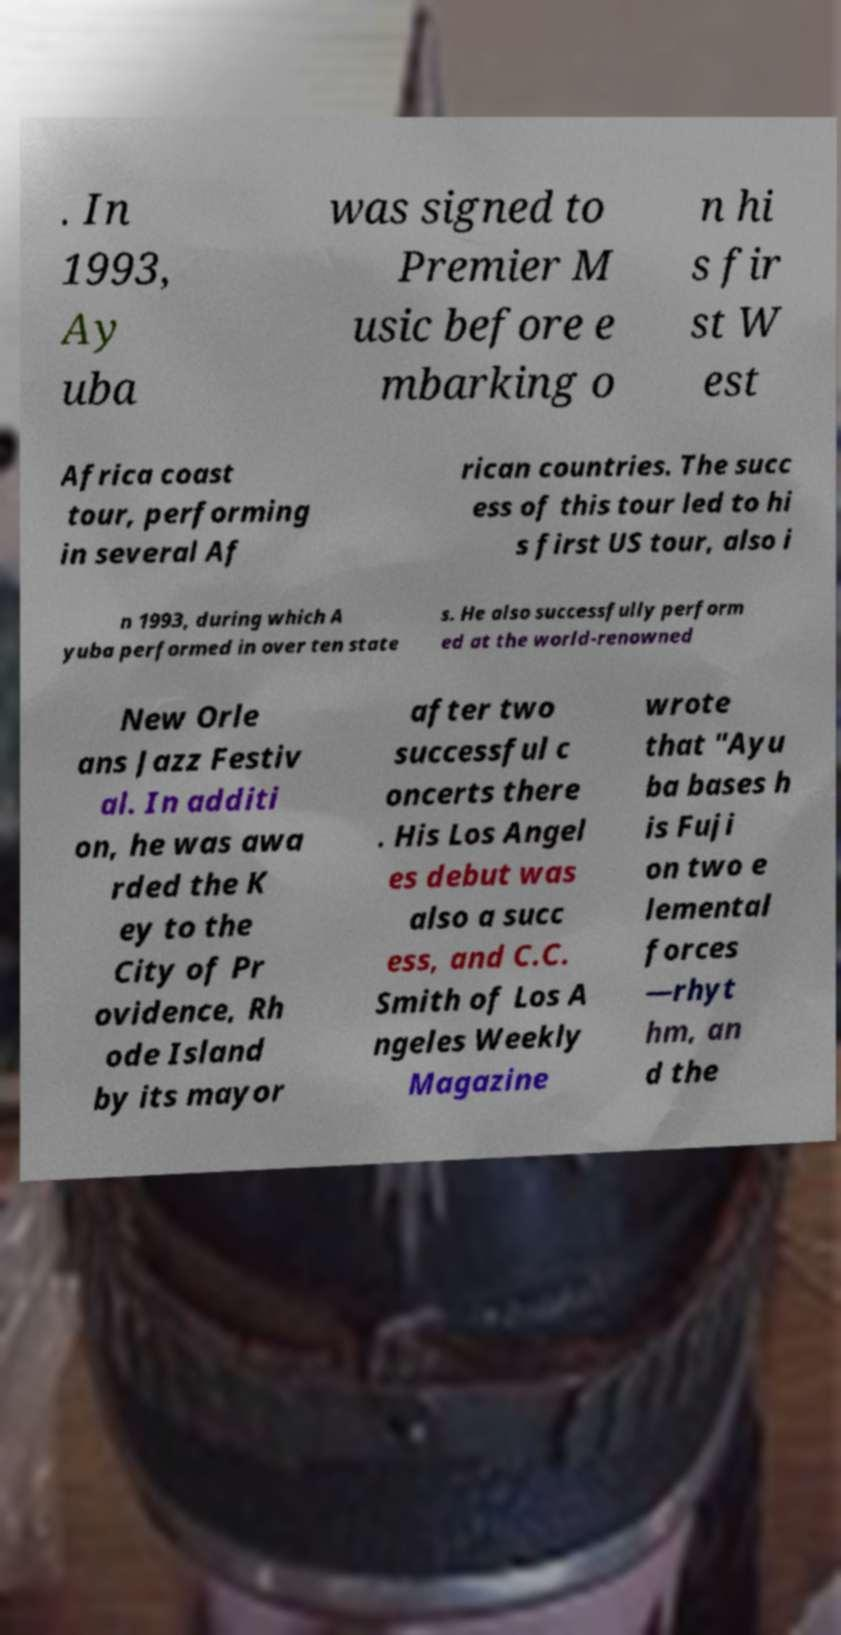Could you assist in decoding the text presented in this image and type it out clearly? . In 1993, Ay uba was signed to Premier M usic before e mbarking o n hi s fir st W est Africa coast tour, performing in several Af rican countries. The succ ess of this tour led to hi s first US tour, also i n 1993, during which A yuba performed in over ten state s. He also successfully perform ed at the world-renowned New Orle ans Jazz Festiv al. In additi on, he was awa rded the K ey to the City of Pr ovidence, Rh ode Island by its mayor after two successful c oncerts there . His Los Angel es debut was also a succ ess, and C.C. Smith of Los A ngeles Weekly Magazine wrote that "Ayu ba bases h is Fuji on two e lemental forces —rhyt hm, an d the 